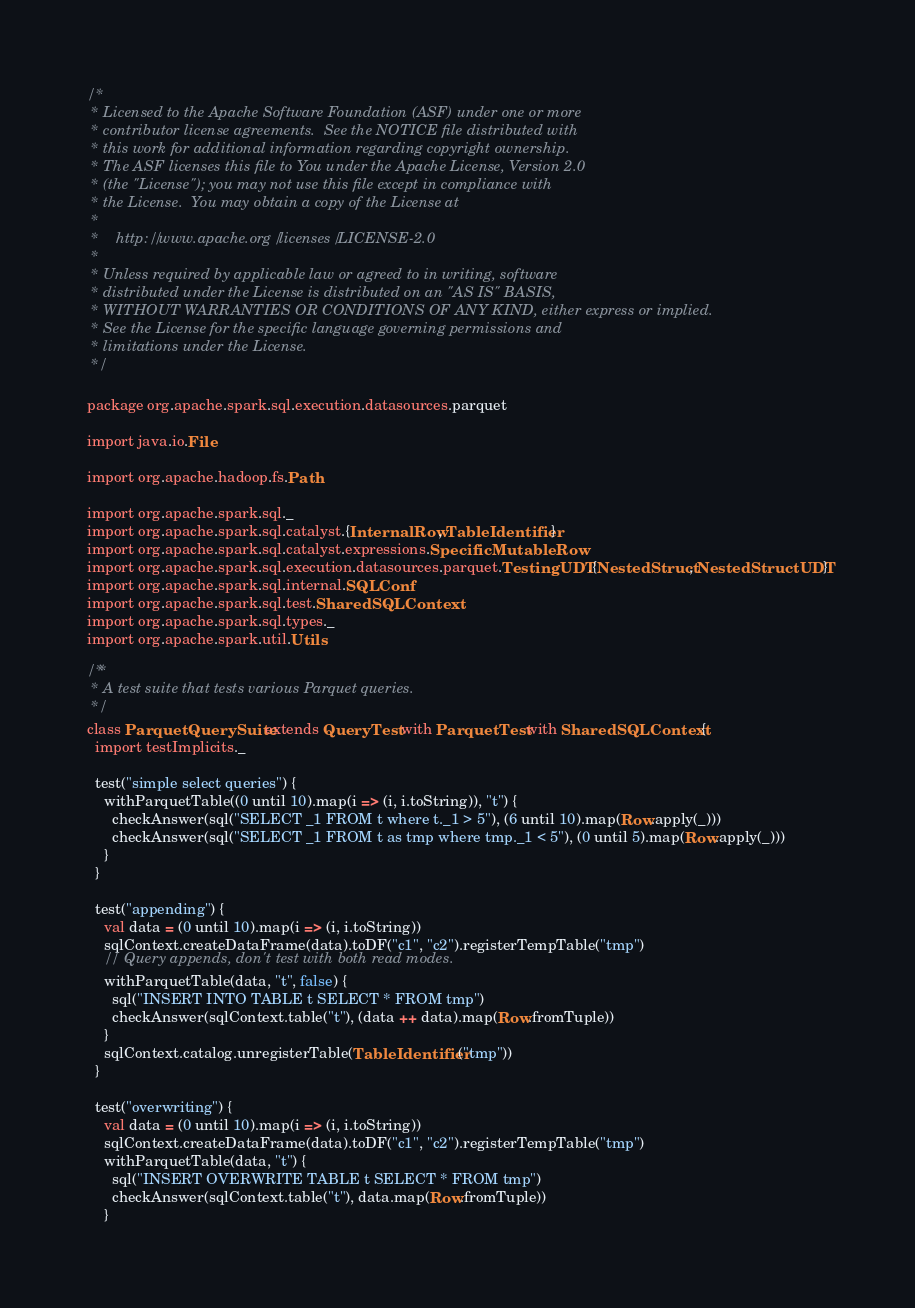<code> <loc_0><loc_0><loc_500><loc_500><_Scala_>/*
 * Licensed to the Apache Software Foundation (ASF) under one or more
 * contributor license agreements.  See the NOTICE file distributed with
 * this work for additional information regarding copyright ownership.
 * The ASF licenses this file to You under the Apache License, Version 2.0
 * (the "License"); you may not use this file except in compliance with
 * the License.  You may obtain a copy of the License at
 *
 *    http://www.apache.org/licenses/LICENSE-2.0
 *
 * Unless required by applicable law or agreed to in writing, software
 * distributed under the License is distributed on an "AS IS" BASIS,
 * WITHOUT WARRANTIES OR CONDITIONS OF ANY KIND, either express or implied.
 * See the License for the specific language governing permissions and
 * limitations under the License.
 */

package org.apache.spark.sql.execution.datasources.parquet

import java.io.File

import org.apache.hadoop.fs.Path

import org.apache.spark.sql._
import org.apache.spark.sql.catalyst.{InternalRow, TableIdentifier}
import org.apache.spark.sql.catalyst.expressions.SpecificMutableRow
import org.apache.spark.sql.execution.datasources.parquet.TestingUDT.{NestedStruct, NestedStructUDT}
import org.apache.spark.sql.internal.SQLConf
import org.apache.spark.sql.test.SharedSQLContext
import org.apache.spark.sql.types._
import org.apache.spark.util.Utils

/**
 * A test suite that tests various Parquet queries.
 */
class ParquetQuerySuite extends QueryTest with ParquetTest with SharedSQLContext {
  import testImplicits._

  test("simple select queries") {
    withParquetTable((0 until 10).map(i => (i, i.toString)), "t") {
      checkAnswer(sql("SELECT _1 FROM t where t._1 > 5"), (6 until 10).map(Row.apply(_)))
      checkAnswer(sql("SELECT _1 FROM t as tmp where tmp._1 < 5"), (0 until 5).map(Row.apply(_)))
    }
  }

  test("appending") {
    val data = (0 until 10).map(i => (i, i.toString))
    sqlContext.createDataFrame(data).toDF("c1", "c2").registerTempTable("tmp")
    // Query appends, don't test with both read modes.
    withParquetTable(data, "t", false) {
      sql("INSERT INTO TABLE t SELECT * FROM tmp")
      checkAnswer(sqlContext.table("t"), (data ++ data).map(Row.fromTuple))
    }
    sqlContext.catalog.unregisterTable(TableIdentifier("tmp"))
  }

  test("overwriting") {
    val data = (0 until 10).map(i => (i, i.toString))
    sqlContext.createDataFrame(data).toDF("c1", "c2").registerTempTable("tmp")
    withParquetTable(data, "t") {
      sql("INSERT OVERWRITE TABLE t SELECT * FROM tmp")
      checkAnswer(sqlContext.table("t"), data.map(Row.fromTuple))
    }</code> 